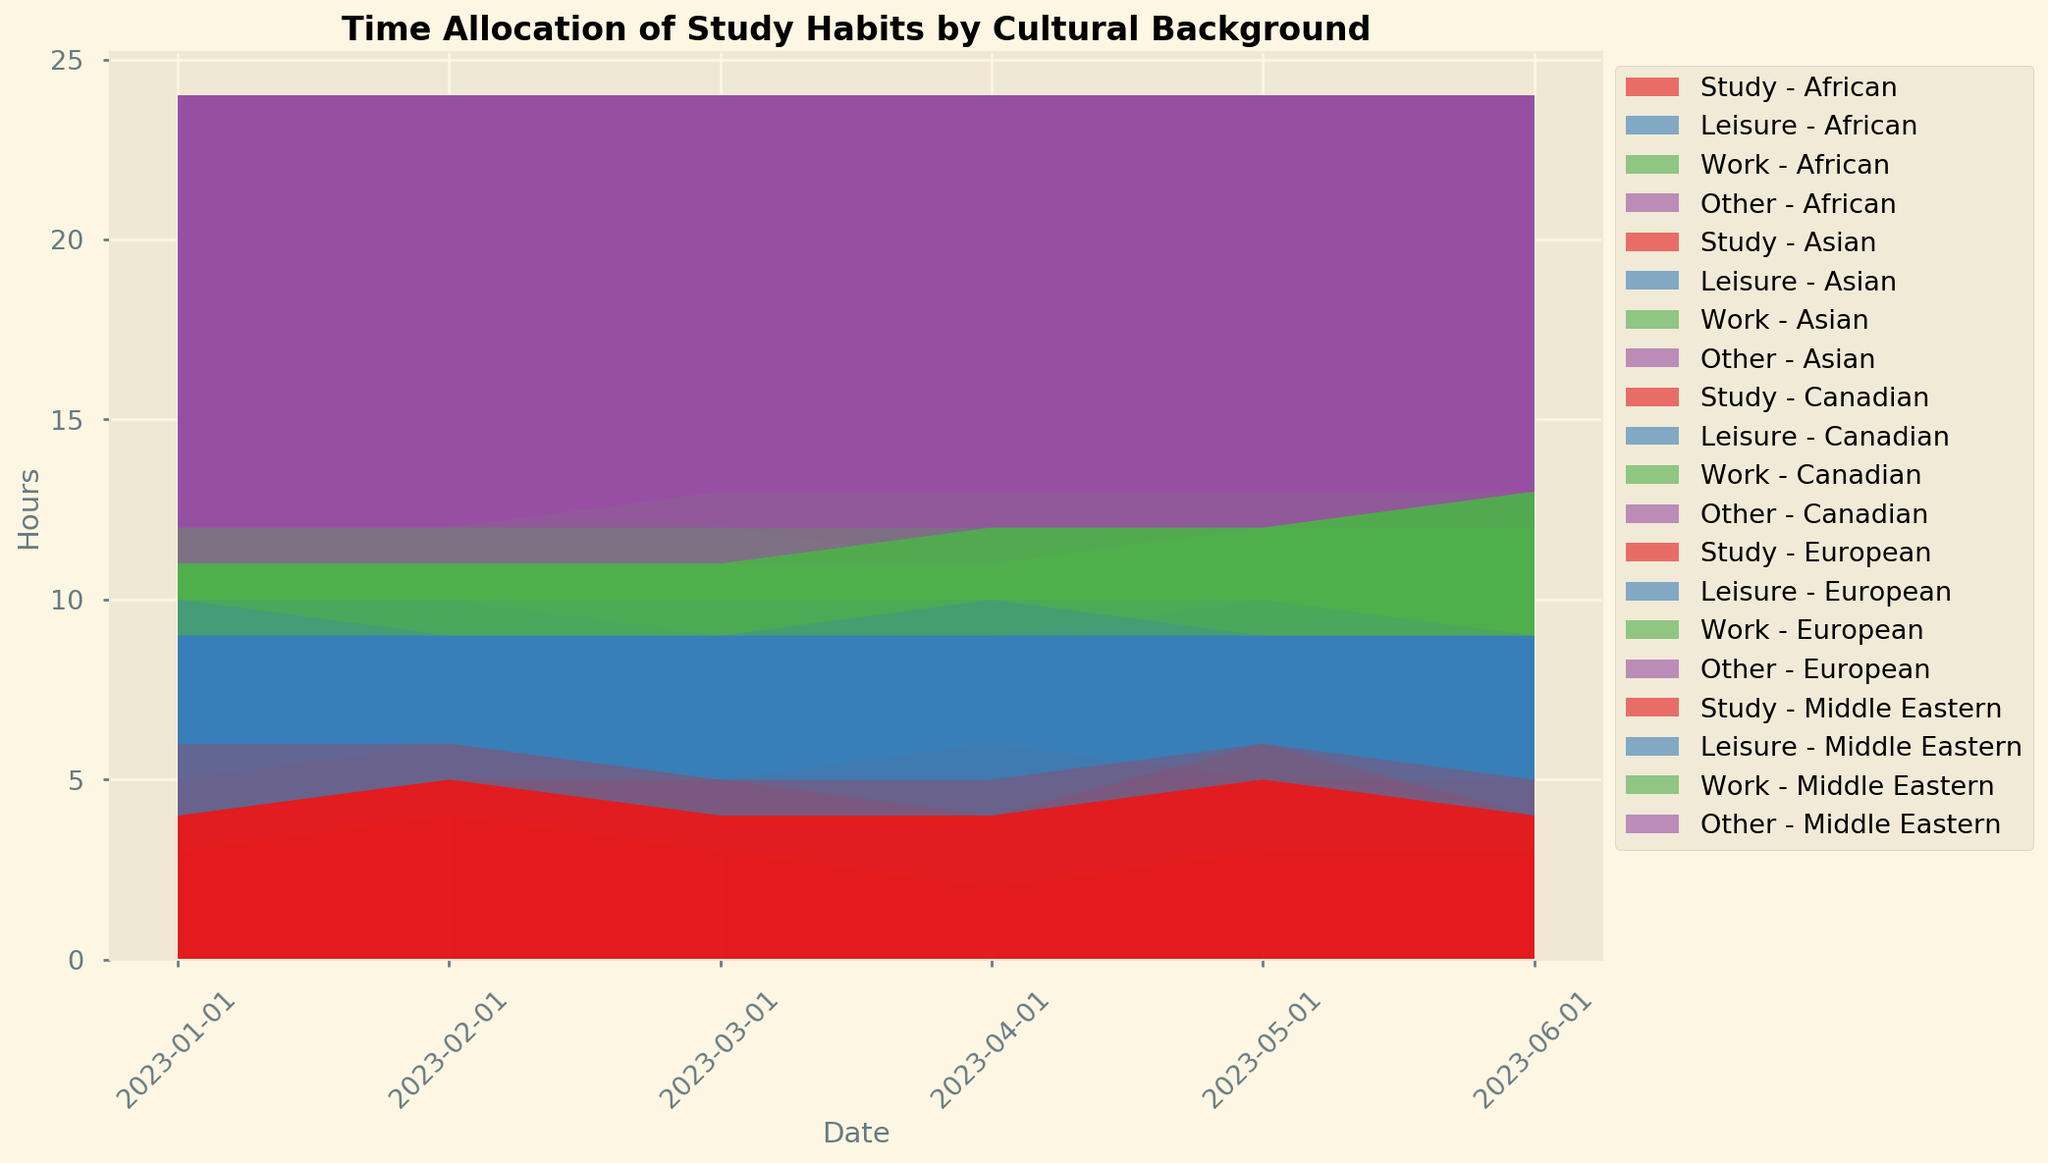What is the approximate average number of hours Asian students spend studying per month? To find the average number of hours Asian students spend studying per month, sum the study hours for each month from January to June and then divide by the number of months. Sum = 5 + 6 + 5 + 6 + 5 + 5 = 32 hours. Divide by 6 months.
Answer: 5.33 hours Between Canadian and African students, who spent more time on leisure activities in April 2023? Compare the leisure hours for Canadian (6 hours) and African students (7 hours) in April 2023. African students spent more hours.
Answer: African Which cultural background showed the largest variation in 'Work' hours from January to June 2023? Calculate the range (max-min) of 'Work' hours for each background. For ‘Canadian’, range=4-2, ‘Asian’, range=3-1, ‘Middle Eastern’, range=4-2, ‘African’, range=4-2, ‘European’, range=4-2. The largest range is 'Asian'.
Answer: Asian In which month did Canadian students spend the highest number of hours studying, and how many hours were those? Look at study hours for Canadian students from January to June. Highest is in May with 6 hours.
Answer: May, 6 hours How did the average leisure time of Middle Eastern students change from January to June 2023? Calculate the average leisure time in Jan, Feb, Mar, Apr, May, and June for Middle Eastern students. Sum = 5 + 4 + 5 + 5 + 4 + 5 = 28 hours. Average = 28 / 6 = 4.67 hours. Compare the average time from start to end and note the trend.
Answer: Stayed roughly the same Did European students or African students allocate more time to leisure activities on average from January to June 2023? Calculate the average leisure hours for European and African students from Jan to June. European: (4+3+4+5+3+4)/6=3.83 hours, African: (7+6+6+7+6+6)/6=6 hours. African students allocated more time.
Answer: African Which cultural group spent the least hours working in February 2023? Look at the ‘Work’ hours across all cultural backgrounds for February 2023. Most hours: Canadian=2, Asian=1, Middle Eastern=2, African=3, European=3. Least is Asian with 1 hour.
Answer: Asian Are there any cultural backgrounds that consistently spent the same number of hours on "Other" activities every month? For each cultural background, check the "Other" hours across all months. Constant values: Asian=13, Middle Eastern=13, European=12. Asian and Middle Eastern students had consistent hours.
Answer: Asian, Middle Eastern What was the trend of study hours for the European group across the first half of 2023? Look at the study hours for European students from January to June. Jan=6, Feb=6, Mar=5, Apr=5, May=6, Jun=5. Find the pattern. The hours showed fluctuation, not consistently increasing or decreasing.
Answer: Fluctuating How do the study hours of Canadian and Middle Eastern students in January 2023 compare? Compare the study hours for January 2023. Canadian=4, Middle Eastern=4. Both studied the same amount of hours.
Answer: Same 